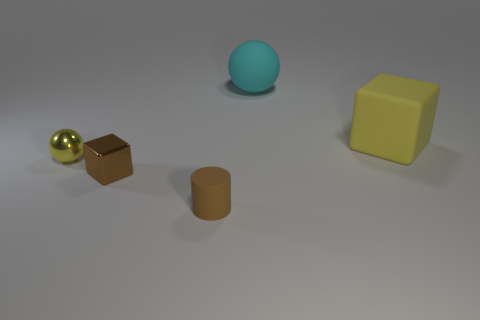Add 5 yellow rubber things. How many objects exist? 10 Subtract all spheres. How many objects are left? 3 Subtract all brown objects. Subtract all red things. How many objects are left? 3 Add 2 small yellow metal things. How many small yellow metal things are left? 3 Add 5 large yellow matte things. How many large yellow matte things exist? 6 Subtract 0 green cylinders. How many objects are left? 5 